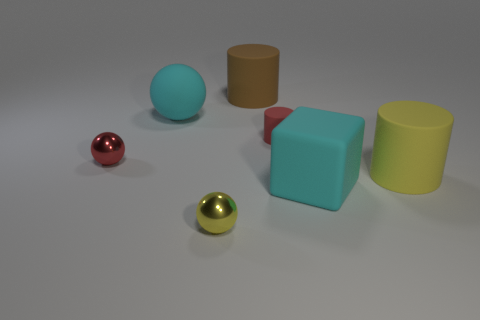What is the big cyan cube made of? Although I cannot physically examine the cube, based on the image, the big cyan cube appears to have a matte surface, typical of an object that could be rendered with digital modeling software, suggesting it's not made of any real material but rather a computer-generated representation of a cube. 